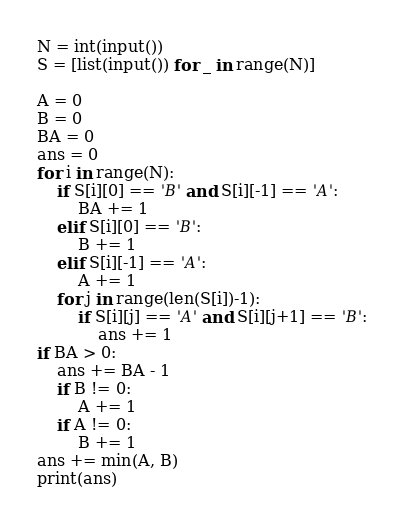Convert code to text. <code><loc_0><loc_0><loc_500><loc_500><_Python_>N = int(input())
S = [list(input()) for _ in range(N)]

A = 0
B = 0
BA = 0
ans = 0
for i in range(N):
    if S[i][0] == 'B' and S[i][-1] == 'A':
        BA += 1
    elif S[i][0] == 'B':
        B += 1
    elif S[i][-1] == 'A':
        A += 1
    for j in range(len(S[i])-1):
        if S[i][j] == 'A' and S[i][j+1] == 'B':
            ans += 1
if BA > 0:
    ans += BA - 1
    if B != 0:
        A += 1
    if A != 0:
        B += 1
ans += min(A, B)
print(ans)
</code> 